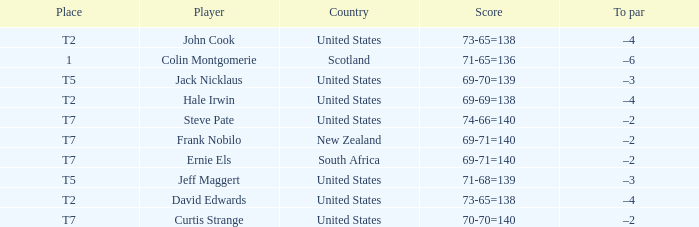What is the name of the golfer that has the score of 73-65=138? John Cook, David Edwards. 